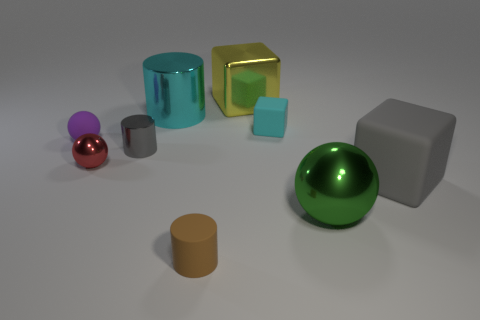Subtract all shiny balls. How many balls are left? 1 Subtract all cylinders. How many objects are left? 6 Subtract 1 balls. How many balls are left? 2 Subtract all gray cylinders. Subtract all gray balls. How many cylinders are left? 2 Subtract all brown spheres. How many brown cylinders are left? 1 Subtract all brown cubes. Subtract all gray metallic objects. How many objects are left? 8 Add 2 cyan metal cylinders. How many cyan metal cylinders are left? 3 Add 8 red shiny blocks. How many red shiny blocks exist? 8 Subtract all green balls. How many balls are left? 2 Subtract 0 purple cylinders. How many objects are left? 9 